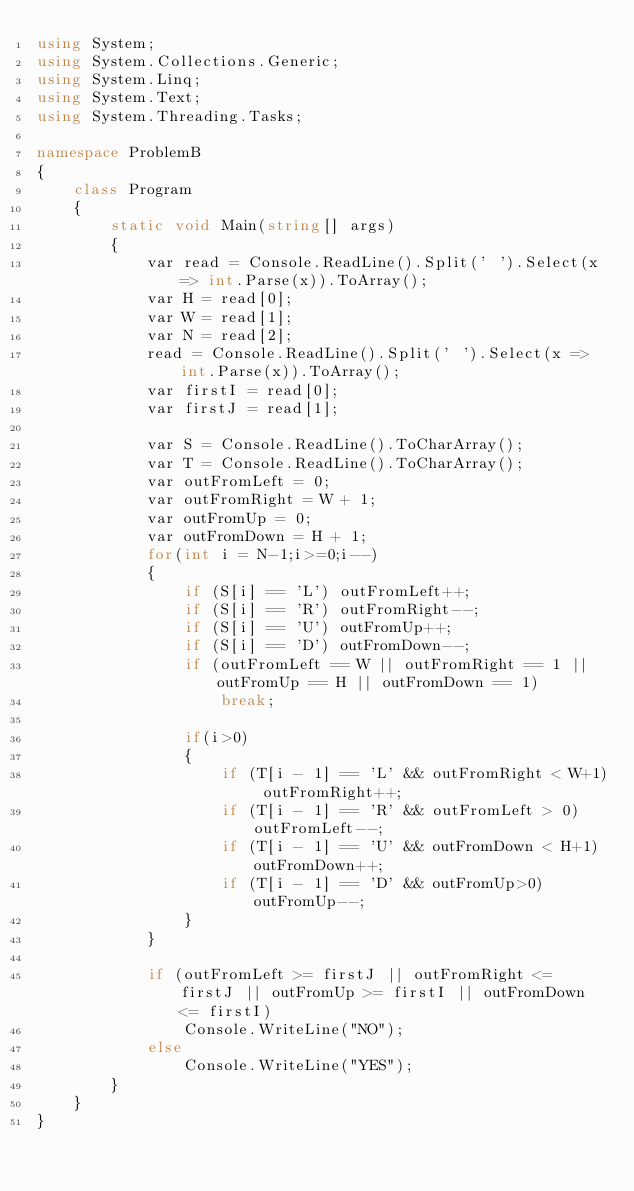Convert code to text. <code><loc_0><loc_0><loc_500><loc_500><_C#_>using System;
using System.Collections.Generic;
using System.Linq;
using System.Text;
using System.Threading.Tasks;

namespace ProblemB
{
    class Program
    {
        static void Main(string[] args)
        {
            var read = Console.ReadLine().Split(' ').Select(x => int.Parse(x)).ToArray();
            var H = read[0];
            var W = read[1];
            var N = read[2];
            read = Console.ReadLine().Split(' ').Select(x => int.Parse(x)).ToArray();
            var firstI = read[0];
            var firstJ = read[1];

            var S = Console.ReadLine().ToCharArray();
            var T = Console.ReadLine().ToCharArray();
            var outFromLeft = 0;
            var outFromRight = W + 1;
            var outFromUp = 0;
            var outFromDown = H + 1;
            for(int i = N-1;i>=0;i--)
            {
                if (S[i] == 'L') outFromLeft++;
                if (S[i] == 'R') outFromRight--;
                if (S[i] == 'U') outFromUp++;
                if (S[i] == 'D') outFromDown--;
                if (outFromLeft == W || outFromRight == 1 || outFromUp == H || outFromDown == 1)
                    break;

                if(i>0)
                {
                    if (T[i - 1] == 'L' && outFromRight < W+1) outFromRight++;
                    if (T[i - 1] == 'R' && outFromLeft > 0) outFromLeft--;
                    if (T[i - 1] == 'U' && outFromDown < H+1) outFromDown++;
                    if (T[i - 1] == 'D' && outFromUp>0) outFromUp--;
                }
            }

            if (outFromLeft >= firstJ || outFromRight <= firstJ || outFromUp >= firstI || outFromDown <= firstI)
                Console.WriteLine("NO");
            else
                Console.WriteLine("YES");
        }
    }
}
</code> 